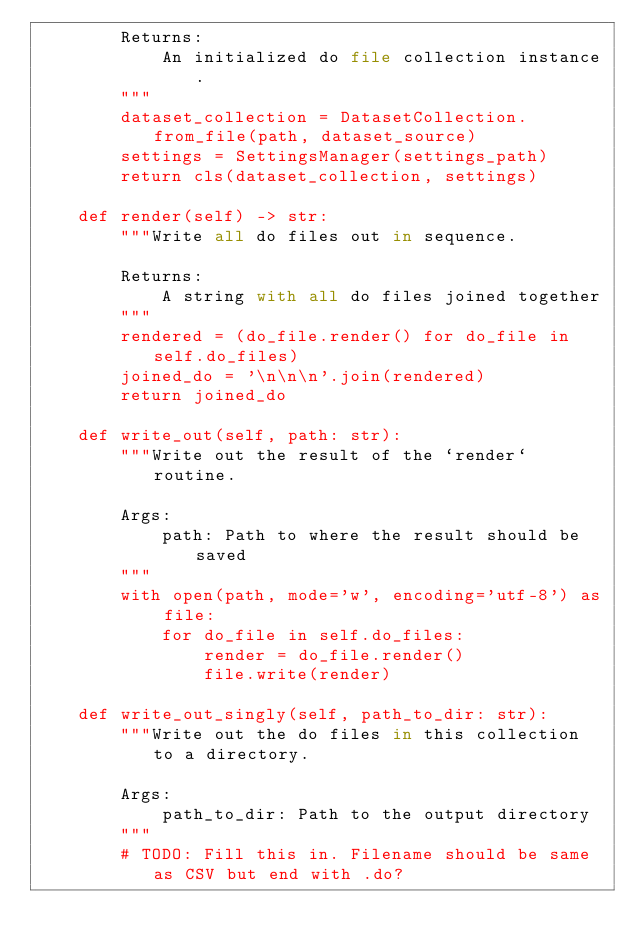Convert code to text. <code><loc_0><loc_0><loc_500><loc_500><_Python_>        Returns:
            An initialized do file collection instance.
        """
        dataset_collection = DatasetCollection.from_file(path, dataset_source)
        settings = SettingsManager(settings_path)
        return cls(dataset_collection, settings)

    def render(self) -> str:
        """Write all do files out in sequence.

        Returns:
            A string with all do files joined together
        """
        rendered = (do_file.render() for do_file in self.do_files)
        joined_do = '\n\n\n'.join(rendered)
        return joined_do

    def write_out(self, path: str):
        """Write out the result of the `render` routine.

        Args:
            path: Path to where the result should be saved
        """
        with open(path, mode='w', encoding='utf-8') as file:
            for do_file in self.do_files:
                render = do_file.render()
                file.write(render)

    def write_out_singly(self, path_to_dir: str):
        """Write out the do files in this collection to a directory.

        Args:
            path_to_dir: Path to the output directory
        """
        # TODO: Fill this in. Filename should be same as CSV but end with .do?
</code> 